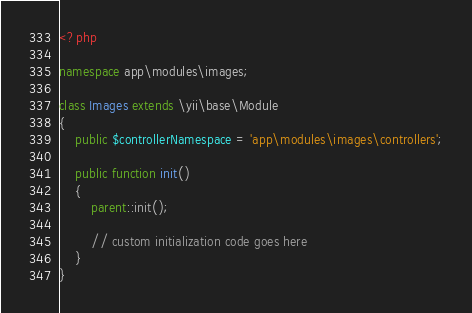Convert code to text. <code><loc_0><loc_0><loc_500><loc_500><_PHP_><?php

namespace app\modules\images;

class Images extends \yii\base\Module
{
    public $controllerNamespace = 'app\modules\images\controllers';

    public function init()
    {
        parent::init();

        // custom initialization code goes here
    }
}
</code> 